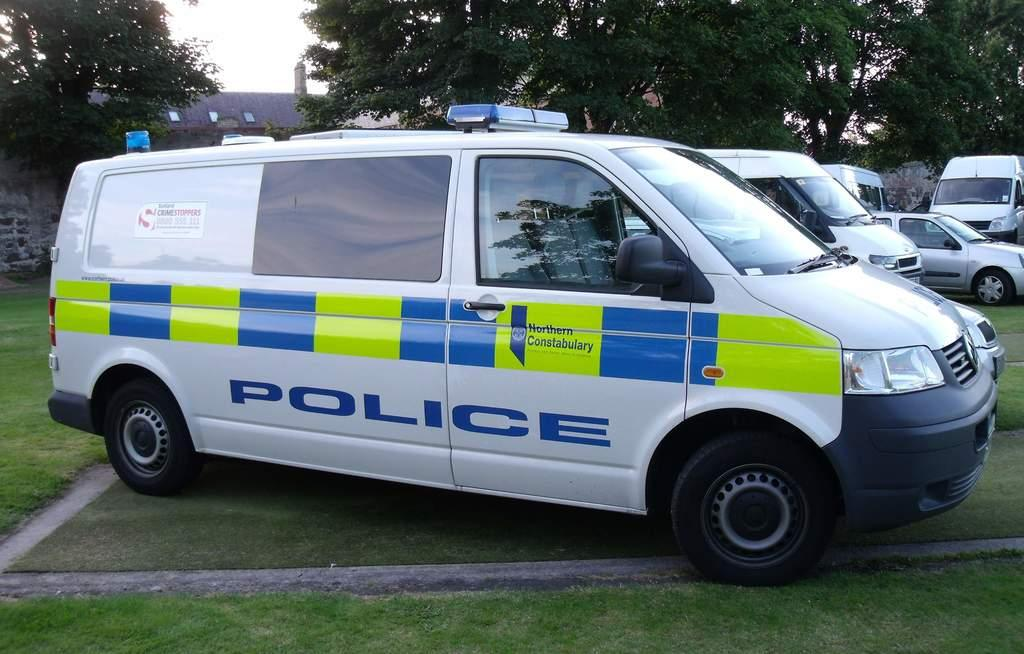<image>
Describe the image concisely. A white van with the word police written on it is parked outside. 